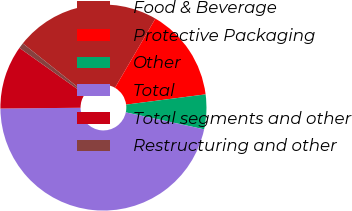<chart> <loc_0><loc_0><loc_500><loc_500><pie_chart><fcel>Food & Beverage<fcel>Protective Packaging<fcel>Other<fcel>Total<fcel>Total segments and other<fcel>Restructuring and other<nl><fcel>22.72%<fcel>14.54%<fcel>5.43%<fcel>46.46%<fcel>9.98%<fcel>0.87%<nl></chart> 